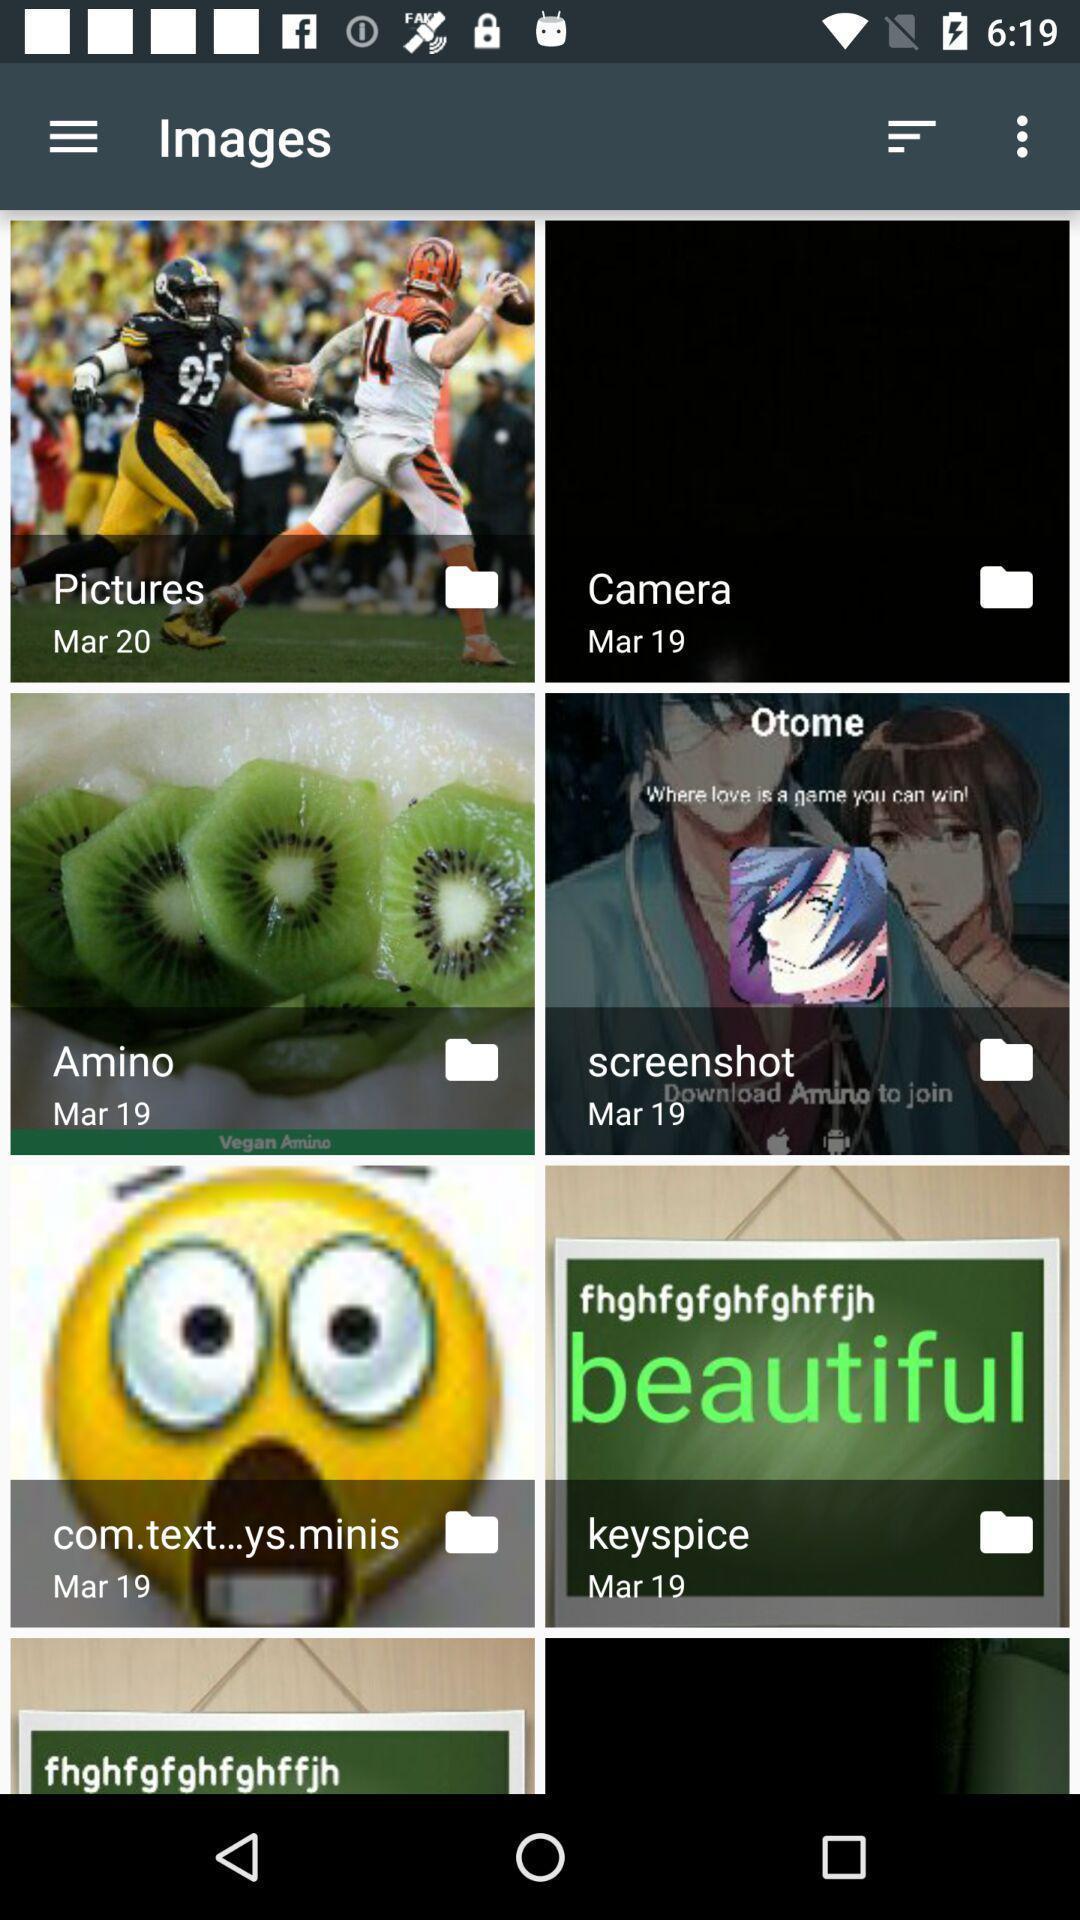Give me a narrative description of this picture. Page displaying various images in social application. 